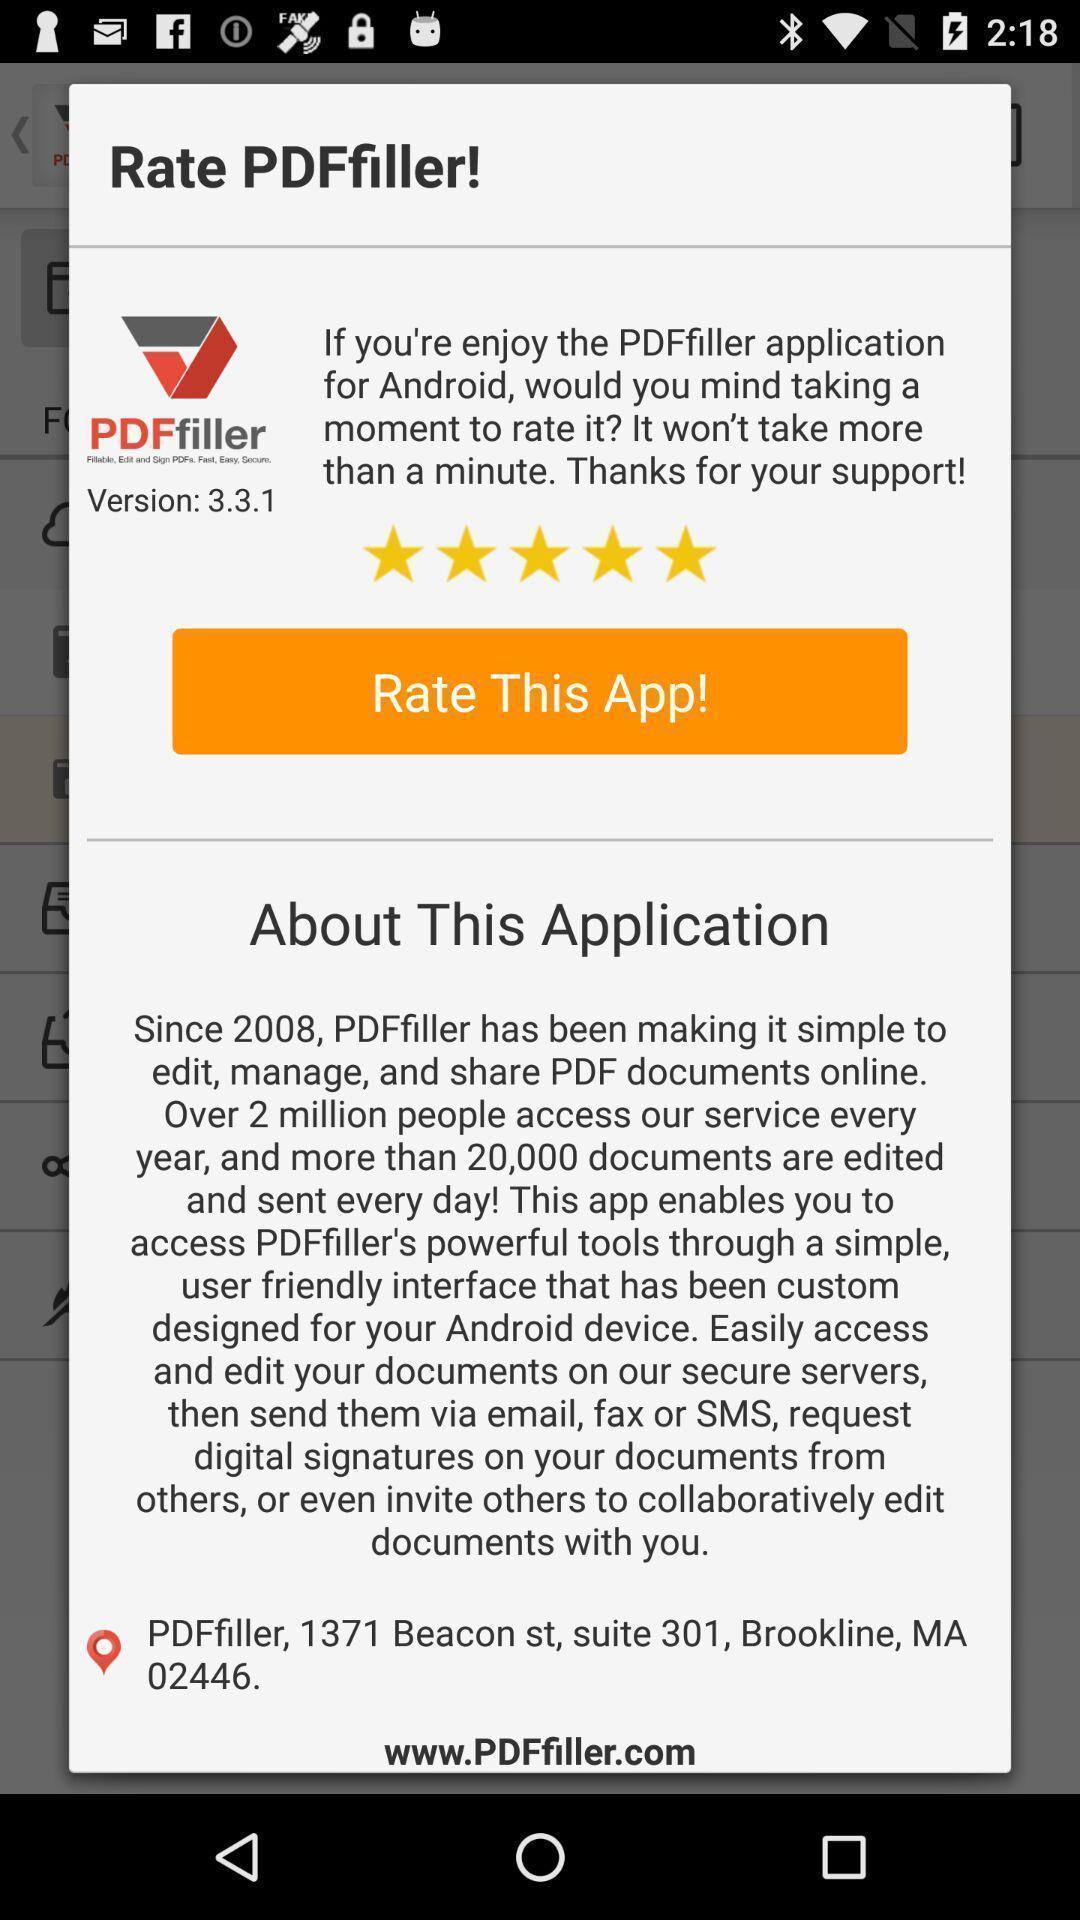Give me a summary of this screen capture. Pop-up shows to rate the app. 